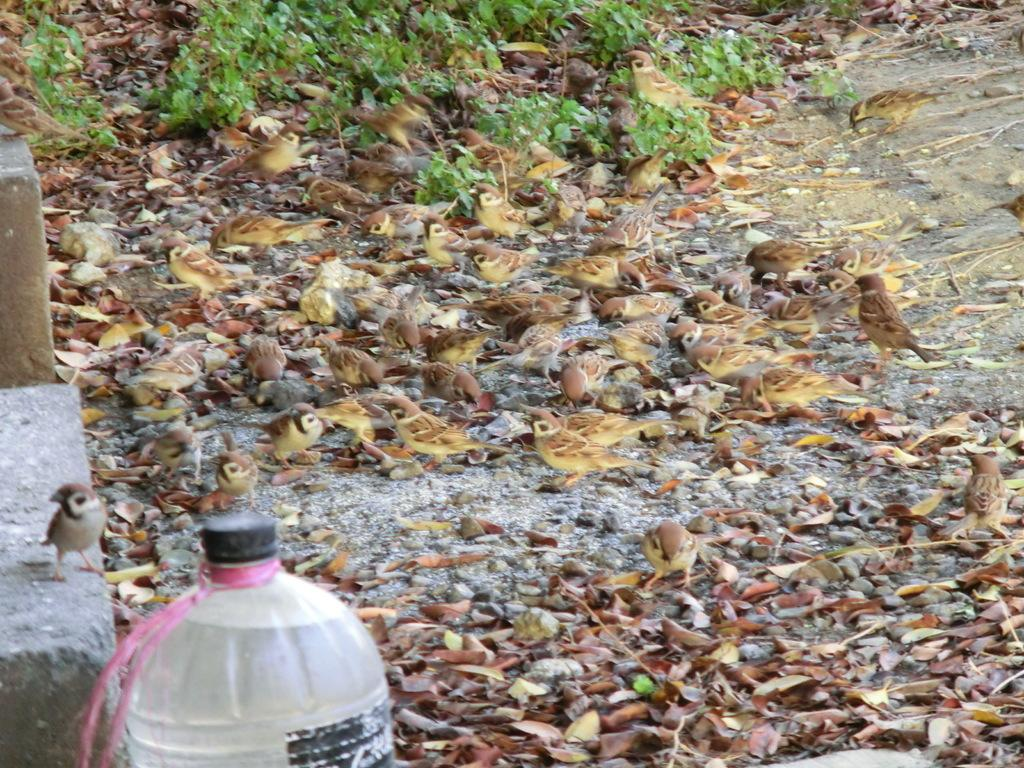What is located in the foreground of the image? There is a bottle in the foreground of the image. What is attached to the bottle? A pink thread is tied to the neck of the bottle. What can be seen in the background of the image? There are birds, leafs on the ground, and plants visible in the background. What type of pest can be seen crawling on the base of the industry in the image? There is no base, industry, or pest present in the image. 